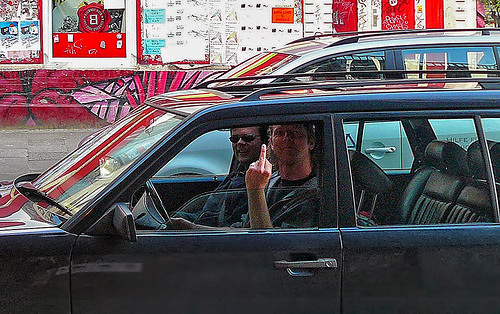<image>
Is the middle finger in front of the looking glass? Yes. The middle finger is positioned in front of the looking glass, appearing closer to the camera viewpoint. 